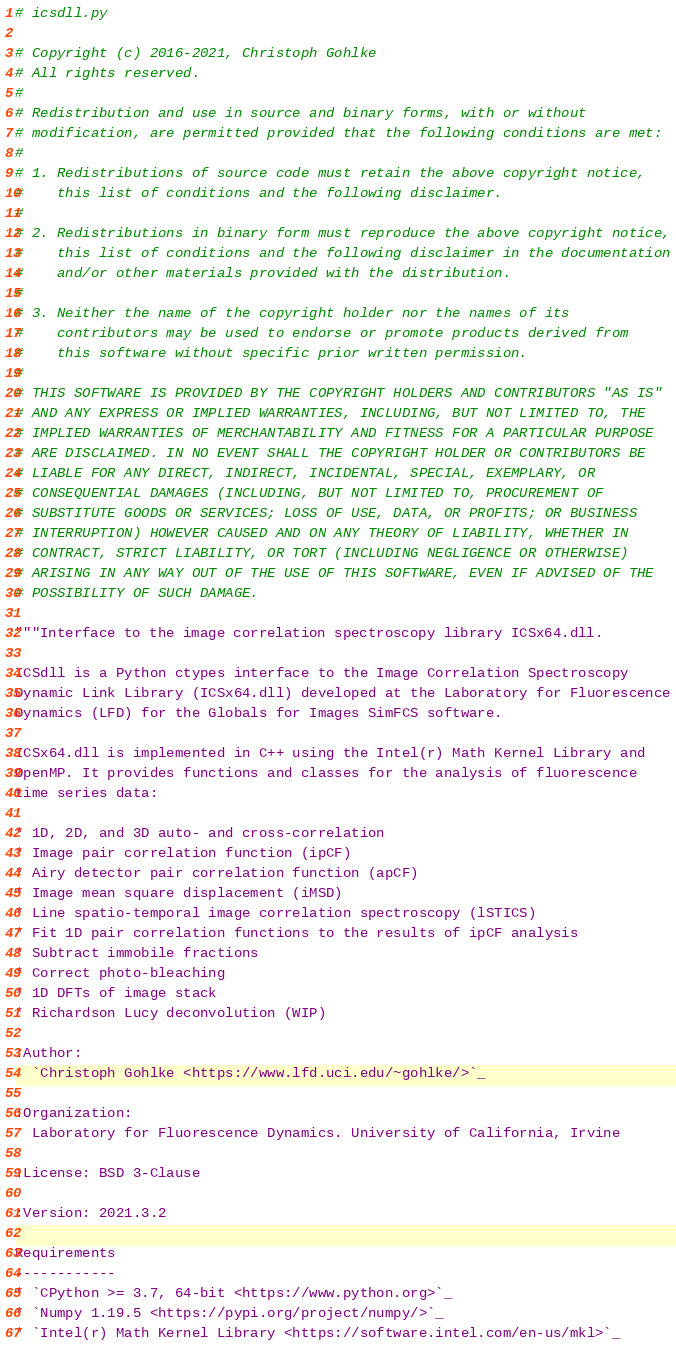<code> <loc_0><loc_0><loc_500><loc_500><_Python_># icsdll.py

# Copyright (c) 2016-2021, Christoph Gohlke
# All rights reserved.
#
# Redistribution and use in source and binary forms, with or without
# modification, are permitted provided that the following conditions are met:
#
# 1. Redistributions of source code must retain the above copyright notice,
#    this list of conditions and the following disclaimer.
#
# 2. Redistributions in binary form must reproduce the above copyright notice,
#    this list of conditions and the following disclaimer in the documentation
#    and/or other materials provided with the distribution.
#
# 3. Neither the name of the copyright holder nor the names of its
#    contributors may be used to endorse or promote products derived from
#    this software without specific prior written permission.
#
# THIS SOFTWARE IS PROVIDED BY THE COPYRIGHT HOLDERS AND CONTRIBUTORS "AS IS"
# AND ANY EXPRESS OR IMPLIED WARRANTIES, INCLUDING, BUT NOT LIMITED TO, THE
# IMPLIED WARRANTIES OF MERCHANTABILITY AND FITNESS FOR A PARTICULAR PURPOSE
# ARE DISCLAIMED. IN NO EVENT SHALL THE COPYRIGHT HOLDER OR CONTRIBUTORS BE
# LIABLE FOR ANY DIRECT, INDIRECT, INCIDENTAL, SPECIAL, EXEMPLARY, OR
# CONSEQUENTIAL DAMAGES (INCLUDING, BUT NOT LIMITED TO, PROCUREMENT OF
# SUBSTITUTE GOODS OR SERVICES; LOSS OF USE, DATA, OR PROFITS; OR BUSINESS
# INTERRUPTION) HOWEVER CAUSED AND ON ANY THEORY OF LIABILITY, WHETHER IN
# CONTRACT, STRICT LIABILITY, OR TORT (INCLUDING NEGLIGENCE OR OTHERWISE)
# ARISING IN ANY WAY OUT OF THE USE OF THIS SOFTWARE, EVEN IF ADVISED OF THE
# POSSIBILITY OF SUCH DAMAGE.

"""Interface to the image correlation spectroscopy library ICSx64.dll.

ICSdll is a Python ctypes interface to the Image Correlation Spectroscopy
Dynamic Link Library (ICSx64.dll) developed at the Laboratory for Fluorescence
Dynamics (LFD) for the Globals for Images SimFCS software.

ICSx64.dll is implemented in C++ using the Intel(r) Math Kernel Library and
OpenMP. It provides functions and classes for the analysis of fluorescence
time series data:

* 1D, 2D, and 3D auto- and cross-correlation
* Image pair correlation function (ipCF)
* Airy detector pair correlation function (apCF)
* Image mean square displacement (iMSD)
* Line spatio-temporal image correlation spectroscopy (lSTICS)
* Fit 1D pair correlation functions to the results of ipCF analysis
* Subtract immobile fractions
* Correct photo-bleaching
* 1D DFTs of image stack
* Richardson Lucy deconvolution (WIP)

:Author:
  `Christoph Gohlke <https://www.lfd.uci.edu/~gohlke/>`_

:Organization:
  Laboratory for Fluorescence Dynamics. University of California, Irvine

:License: BSD 3-Clause

:Version: 2021.3.2

Requirements
------------
* `CPython >= 3.7, 64-bit <https://www.python.org>`_
* `Numpy 1.19.5 <https://pypi.org/project/numpy/>`_
* `Intel(r) Math Kernel Library <https://software.intel.com/en-us/mkl>`_</code> 